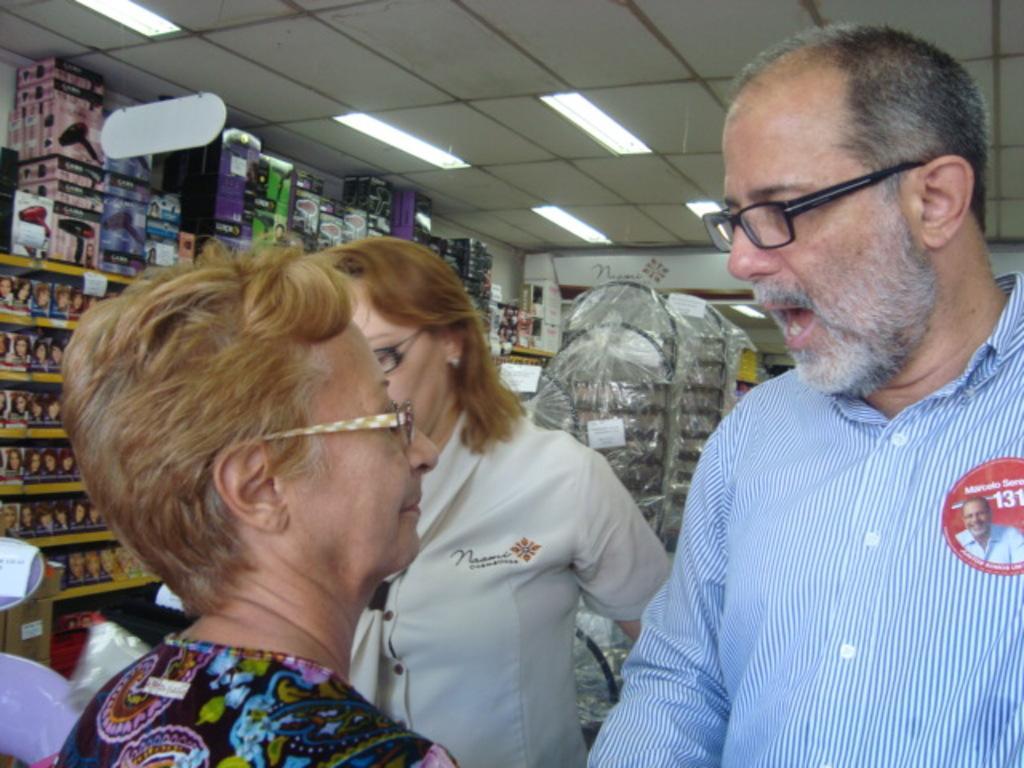Can you describe this image briefly? There are three persons and they have spectacles. In the background we can see a rack, boxes, and lights. This is roof. 